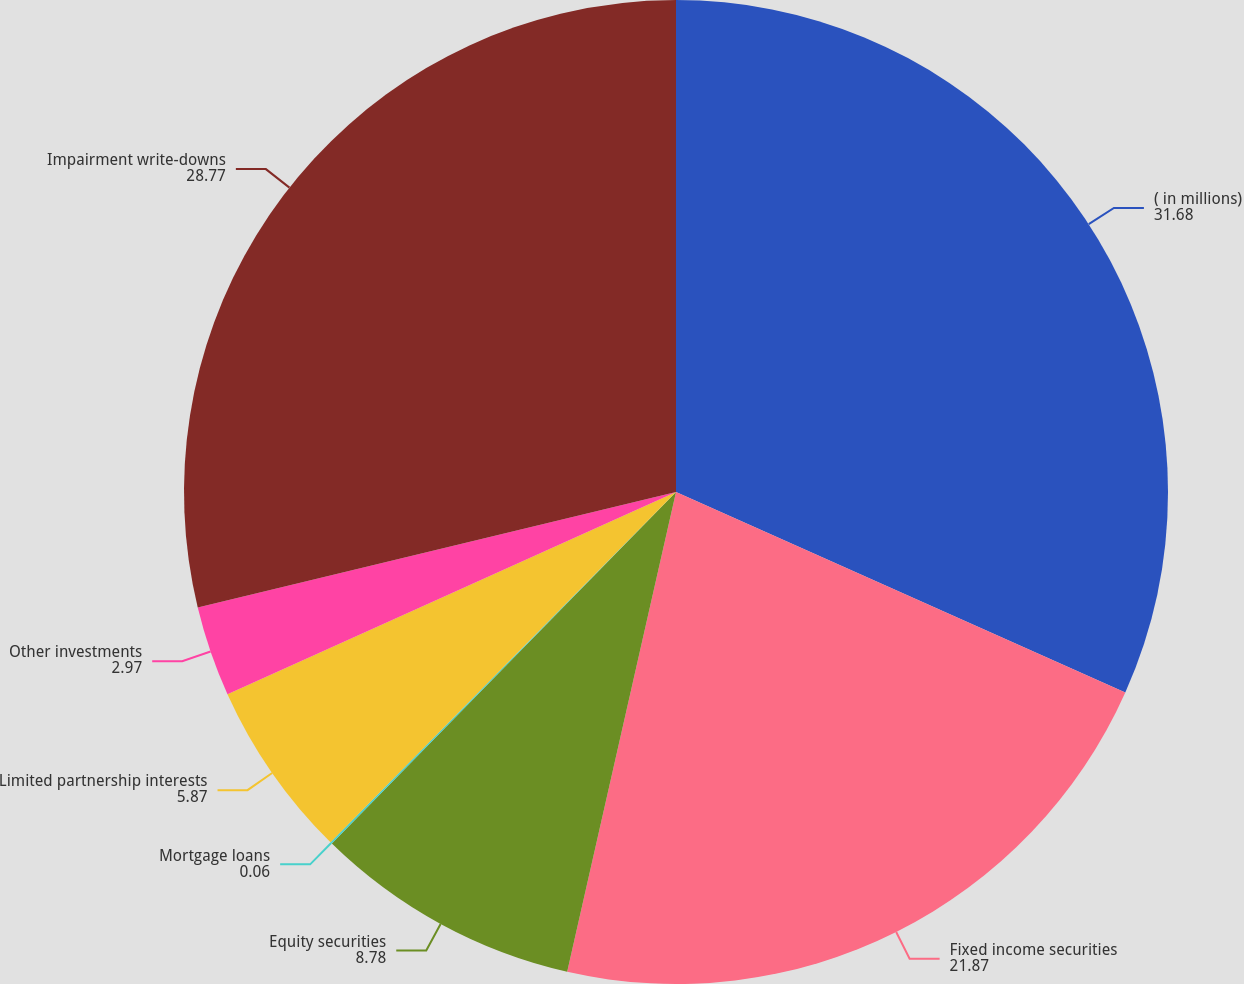<chart> <loc_0><loc_0><loc_500><loc_500><pie_chart><fcel>( in millions)<fcel>Fixed income securities<fcel>Equity securities<fcel>Mortgage loans<fcel>Limited partnership interests<fcel>Other investments<fcel>Impairment write-downs<nl><fcel>31.68%<fcel>21.87%<fcel>8.78%<fcel>0.06%<fcel>5.87%<fcel>2.97%<fcel>28.77%<nl></chart> 